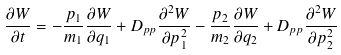Convert formula to latex. <formula><loc_0><loc_0><loc_500><loc_500>\frac { \partial W } { \partial t } = - \frac { p _ { 1 } } { m _ { 1 } } \frac { \partial W } { \partial q _ { 1 } } + D _ { p p } \frac { \partial ^ { 2 } W } { \partial p _ { 1 } ^ { 2 } } - \frac { p _ { 2 } } { m _ { 2 } } \frac { \partial W } { \partial q _ { 2 } } + D _ { p p } \frac { \partial ^ { 2 } W } { \partial p _ { 2 } ^ { 2 } }</formula> 